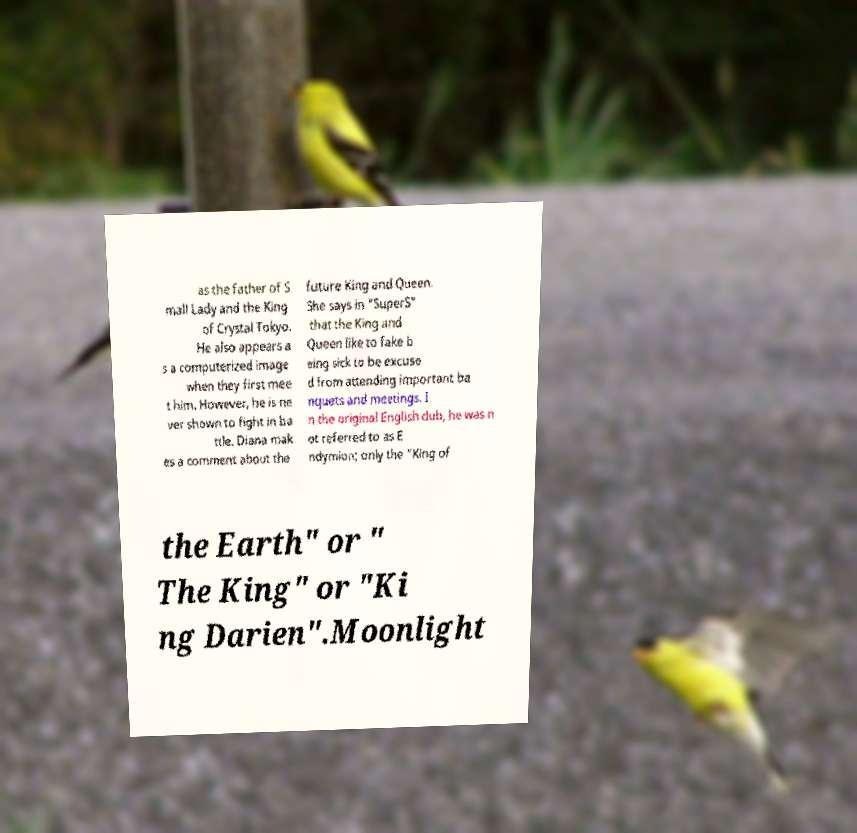Could you assist in decoding the text presented in this image and type it out clearly? as the father of S mall Lady and the King of Crystal Tokyo. He also appears a s a computerized image when they first mee t him. However, he is ne ver shown to fight in ba ttle. Diana mak es a comment about the future King and Queen. She says in "SuperS" that the King and Queen like to fake b eing sick to be excuse d from attending important ba nquets and meetings. I n the original English dub, he was n ot referred to as E ndymion; only the "King of the Earth" or " The King" or "Ki ng Darien".Moonlight 